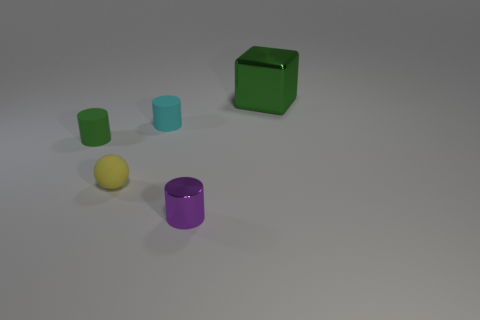There is a cyan rubber thing that is the same size as the purple shiny object; what is its shape?
Your answer should be very brief. Cylinder. There is a small thing that is the same color as the big metal block; what is its shape?
Give a very brief answer. Cylinder. Are there more brown metal cylinders than cubes?
Provide a short and direct response. No. What material is the cyan object that is the same shape as the purple thing?
Provide a succinct answer. Rubber. Does the small cyan object have the same material as the large thing?
Give a very brief answer. No. Are there more tiny cyan objects to the left of the tiny green matte cylinder than green matte things?
Make the answer very short. No. What is the material of the green thing that is on the right side of the shiny object that is in front of the green object that is to the right of the shiny cylinder?
Your response must be concise. Metal. What number of objects are either matte spheres or cylinders that are to the left of the purple metal cylinder?
Your answer should be compact. 3. Does the small metallic cylinder in front of the tiny matte ball have the same color as the large thing?
Ensure brevity in your answer.  No. Are there more green rubber objects that are behind the small green matte thing than tiny rubber objects in front of the cyan cylinder?
Offer a terse response. No. 